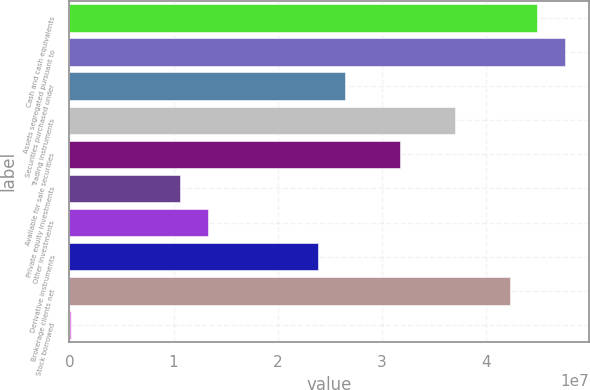Convert chart to OTSL. <chart><loc_0><loc_0><loc_500><loc_500><bar_chart><fcel>Cash and cash equivalents<fcel>Assets segregated pursuant to<fcel>Securities purchased under<fcel>Trading instruments<fcel>Available for sale securities<fcel>Private equity investments<fcel>Other investments<fcel>Derivative instruments<fcel>Brokerage clients net<fcel>Stock borrowed<nl><fcel>4.49086e+07<fcel>4.7543e+07<fcel>2.6468e+07<fcel>3.70055e+07<fcel>3.17368e+07<fcel>1.06618e+07<fcel>1.32962e+07<fcel>2.38337e+07<fcel>4.22742e+07<fcel>124373<nl></chart> 